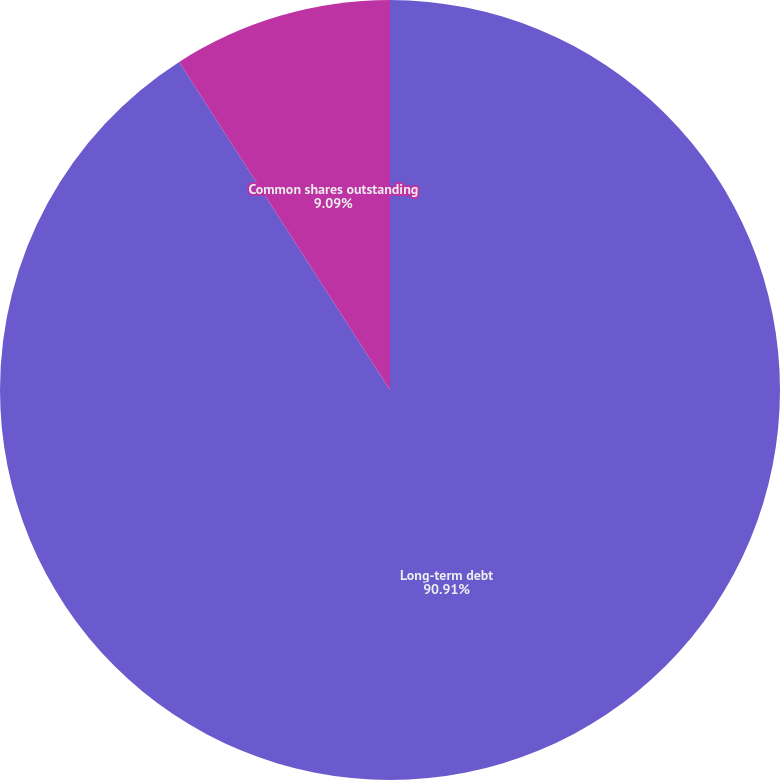Convert chart. <chart><loc_0><loc_0><loc_500><loc_500><pie_chart><fcel>Cash dividends per common<fcel>Long-term debt<fcel>Common shares outstanding<nl><fcel>0.0%<fcel>90.9%<fcel>9.09%<nl></chart> 